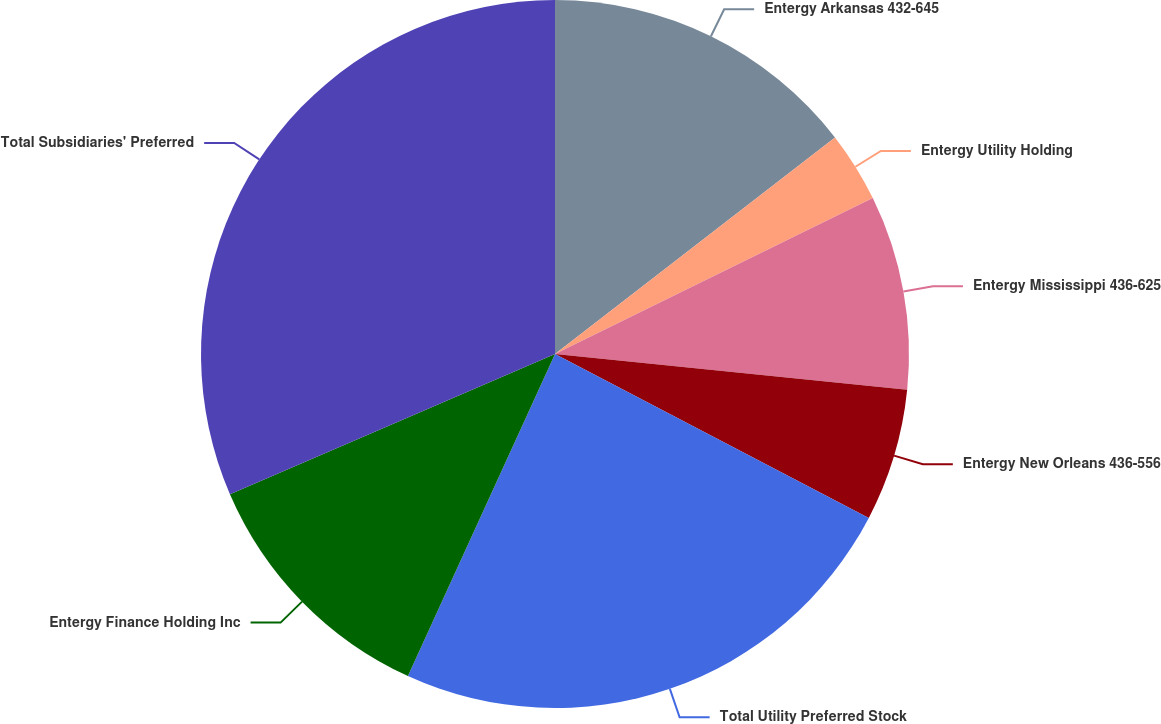Convert chart to OTSL. <chart><loc_0><loc_0><loc_500><loc_500><pie_chart><fcel>Entergy Arkansas 432-645<fcel>Entergy Utility Holding<fcel>Entergy Mississippi 436-625<fcel>Entergy New Orleans 436-556<fcel>Total Utility Preferred Stock<fcel>Entergy Finance Holding Inc<fcel>Total Subsidiaries' Preferred<nl><fcel>14.52%<fcel>3.22%<fcel>8.87%<fcel>6.05%<fcel>24.16%<fcel>11.7%<fcel>31.48%<nl></chart> 